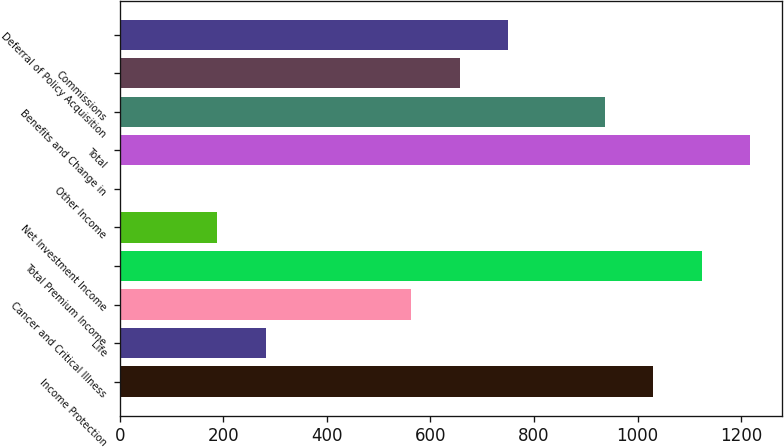Convert chart to OTSL. <chart><loc_0><loc_0><loc_500><loc_500><bar_chart><fcel>Income Protection<fcel>Life<fcel>Cancer and Critical Illness<fcel>Total Premium Income<fcel>Net Investment Income<fcel>Other Income<fcel>Total<fcel>Benefits and Change in<fcel>Commissions<fcel>Deferral of Policy Acquisition<nl><fcel>1030.37<fcel>281.81<fcel>562.52<fcel>1123.94<fcel>188.24<fcel>1.1<fcel>1217.51<fcel>936.8<fcel>656.09<fcel>749.66<nl></chart> 